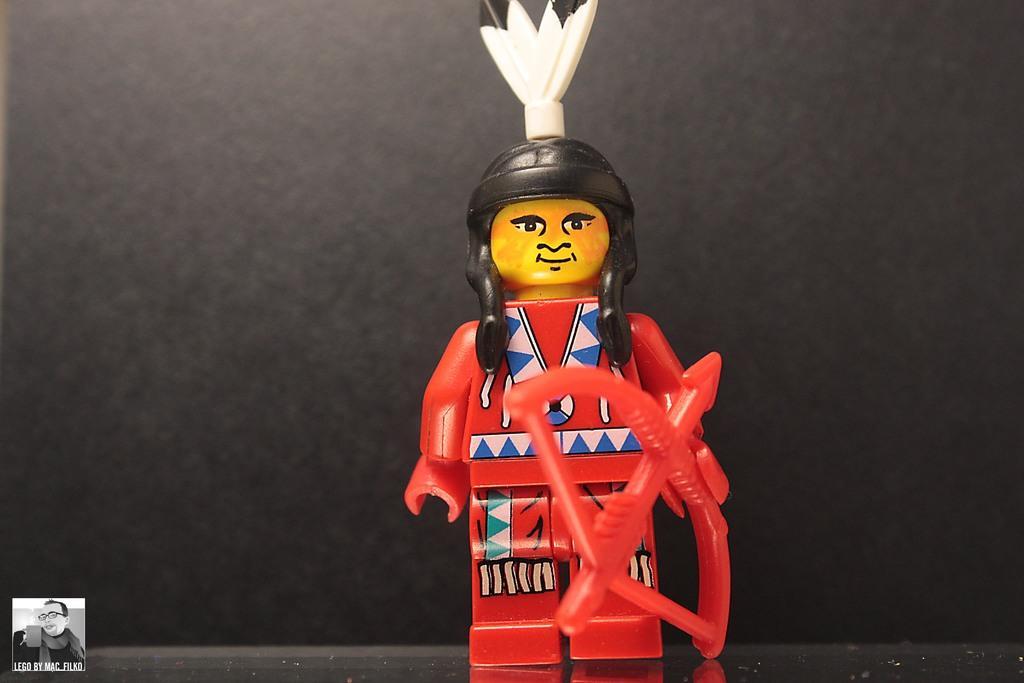Can you describe this image briefly? In this image we can see a Lego toy of a person holding a bow and arrow, it is placed on a surface and on the bottom left corner of the image there is a logo. 